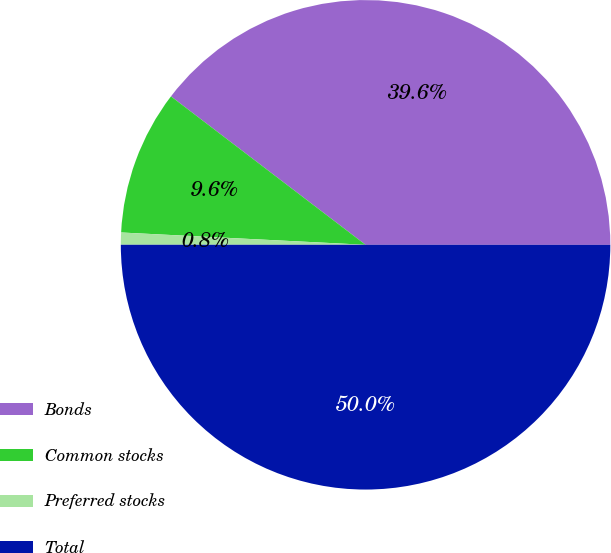Convert chart. <chart><loc_0><loc_0><loc_500><loc_500><pie_chart><fcel>Bonds<fcel>Common stocks<fcel>Preferred stocks<fcel>Total<nl><fcel>39.64%<fcel>9.57%<fcel>0.8%<fcel>50.0%<nl></chart> 